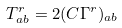Convert formula to latex. <formula><loc_0><loc_0><loc_500><loc_500>T _ { a b } ^ { r } = 2 ( C \Gamma ^ { r } ) _ { a b }</formula> 